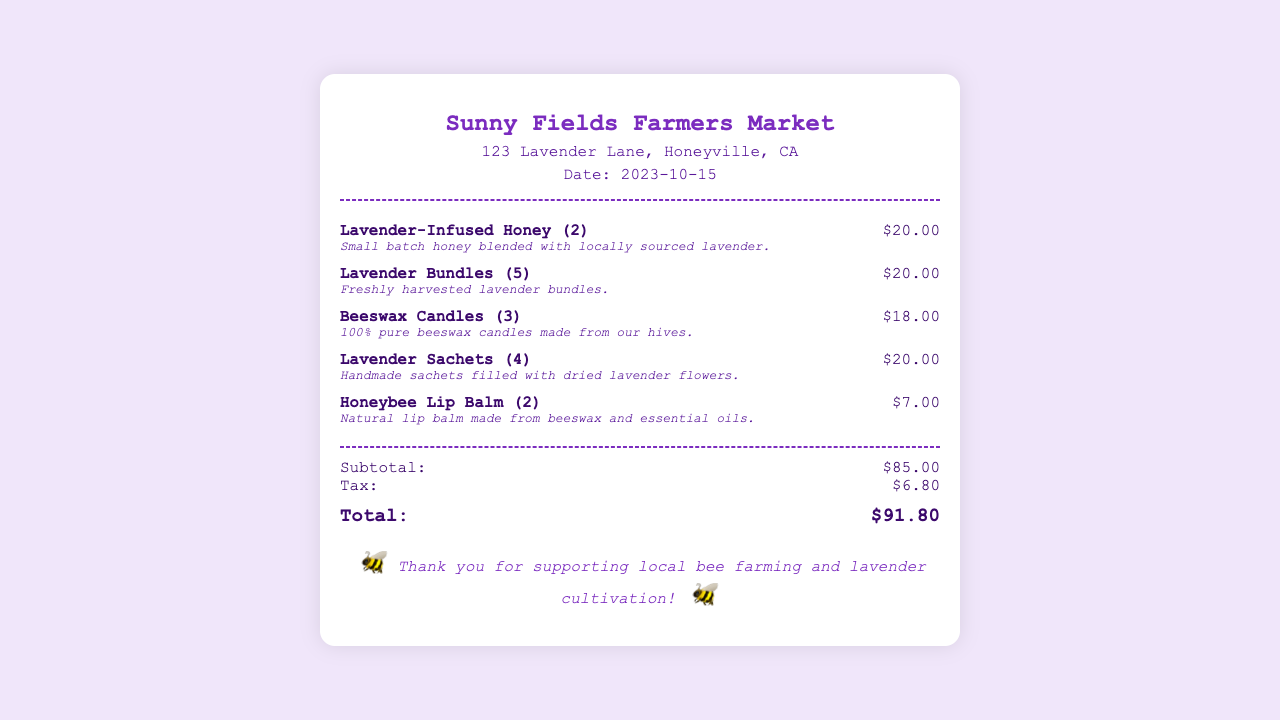What is the date of the receipt? The date of the receipt is clearly mentioned in the document, which is 2023-10-15.
Answer: 2023-10-15 How many Lavender-Infused Honey items were purchased? The receipt indicates that 2 units of Lavender-Infused Honey were purchased.
Answer: 2 What is the total amount before tax? The subtotal, which represents the total amount before tax, is listed as $85.00.
Answer: $85.00 What is the tax amount charged? The receipt specifies that the tax amount is $6.80.
Answer: $6.80 How many different products are listed in the receipt? The total number of different products can be counted from the items section of the receipt, which lists 5 different products.
Answer: 5 What product category is included in the purchase that uses beeswax? The document lists Beeswax Candles and Honeybee Lip Balm as products made with beeswax.
Answer: Beeswax Candles, Honeybee Lip Balm What is the grand total for the purchase? The grand total at the bottom of the receipt indicates the full amount payable, which is $91.80.
Answer: $91.80 What is the address of the Farmers Market? The address of the Farmers Market can be found in the header section of the receipt, which is 123 Lavender Lane, Honeyville, CA.
Answer: 123 Lavender Lane, Honeyville, CA What type of lavender product is mentioned as freshly harvested? The receipt lists Lavender Bundles specifically as freshly harvested lavender products.
Answer: Lavender Bundles 